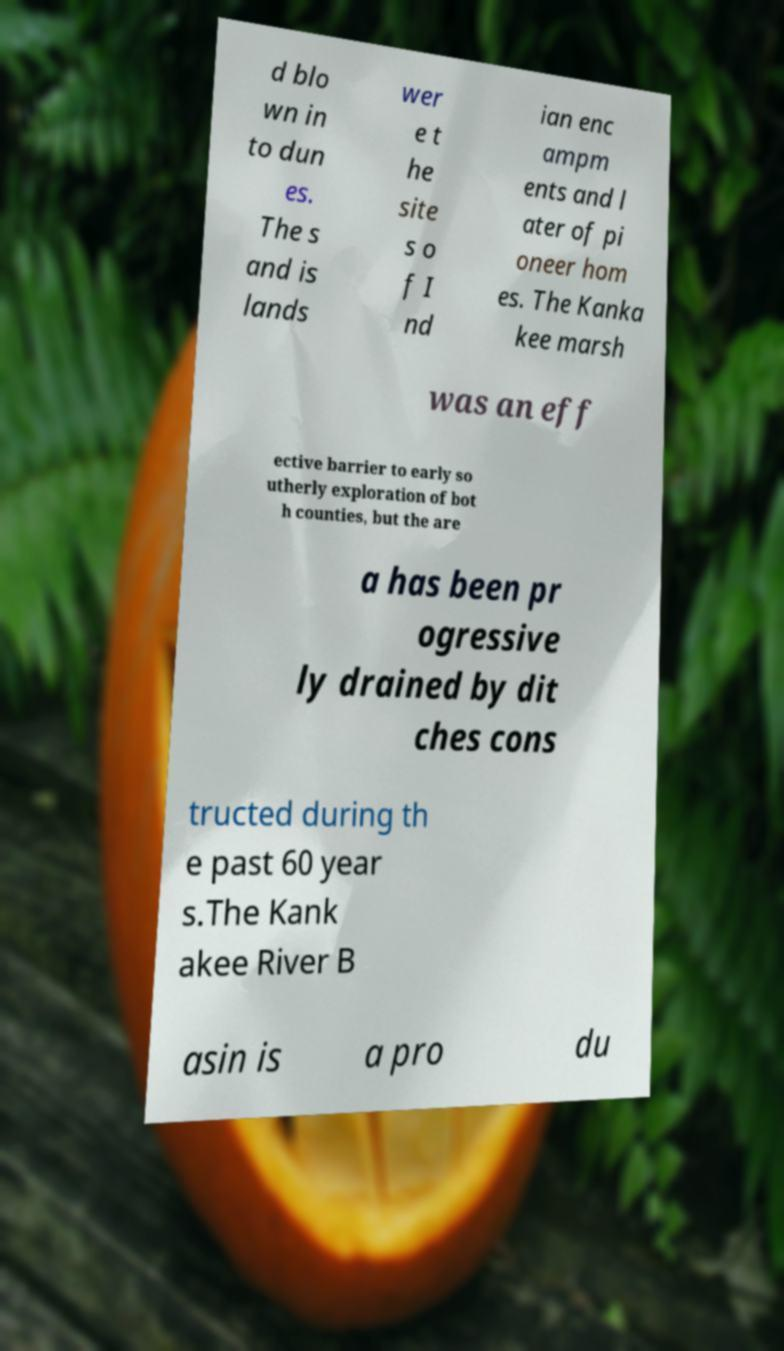Can you accurately transcribe the text from the provided image for me? d blo wn in to dun es. The s and is lands wer e t he site s o f I nd ian enc ampm ents and l ater of pi oneer hom es. The Kanka kee marsh was an eff ective barrier to early so utherly exploration of bot h counties, but the are a has been pr ogressive ly drained by dit ches cons tructed during th e past 60 year s.The Kank akee River B asin is a pro du 